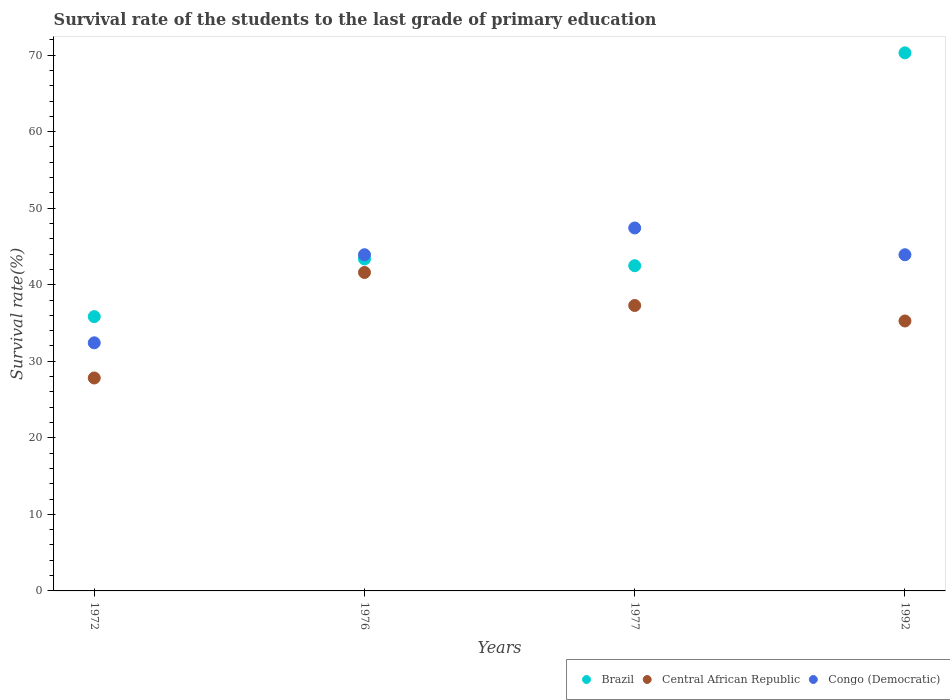How many different coloured dotlines are there?
Ensure brevity in your answer.  3. Is the number of dotlines equal to the number of legend labels?
Ensure brevity in your answer.  Yes. What is the survival rate of the students in Brazil in 1972?
Ensure brevity in your answer.  35.84. Across all years, what is the maximum survival rate of the students in Congo (Democratic)?
Make the answer very short. 47.42. Across all years, what is the minimum survival rate of the students in Brazil?
Provide a succinct answer. 35.84. In which year was the survival rate of the students in Central African Republic maximum?
Ensure brevity in your answer.  1976. What is the total survival rate of the students in Central African Republic in the graph?
Your answer should be very brief. 141.98. What is the difference between the survival rate of the students in Central African Republic in 1972 and that in 1992?
Provide a succinct answer. -7.45. What is the difference between the survival rate of the students in Brazil in 1992 and the survival rate of the students in Congo (Democratic) in 1976?
Give a very brief answer. 26.38. What is the average survival rate of the students in Congo (Democratic) per year?
Ensure brevity in your answer.  41.92. In the year 1992, what is the difference between the survival rate of the students in Brazil and survival rate of the students in Congo (Democratic)?
Offer a very short reply. 26.38. What is the ratio of the survival rate of the students in Congo (Democratic) in 1972 to that in 1977?
Your answer should be compact. 0.68. Is the survival rate of the students in Central African Republic in 1972 less than that in 1976?
Your answer should be very brief. Yes. What is the difference between the highest and the second highest survival rate of the students in Brazil?
Keep it short and to the point. 26.93. What is the difference between the highest and the lowest survival rate of the students in Central African Republic?
Make the answer very short. 13.79. Is the sum of the survival rate of the students in Brazil in 1976 and 1992 greater than the maximum survival rate of the students in Congo (Democratic) across all years?
Provide a succinct answer. Yes. Is the survival rate of the students in Congo (Democratic) strictly greater than the survival rate of the students in Central African Republic over the years?
Make the answer very short. Yes. Is the survival rate of the students in Central African Republic strictly less than the survival rate of the students in Brazil over the years?
Your response must be concise. Yes. How many dotlines are there?
Your answer should be compact. 3. How many years are there in the graph?
Your answer should be very brief. 4. What is the difference between two consecutive major ticks on the Y-axis?
Your answer should be very brief. 10. Are the values on the major ticks of Y-axis written in scientific E-notation?
Give a very brief answer. No. Does the graph contain any zero values?
Offer a terse response. No. Does the graph contain grids?
Make the answer very short. No. Where does the legend appear in the graph?
Ensure brevity in your answer.  Bottom right. How are the legend labels stacked?
Ensure brevity in your answer.  Horizontal. What is the title of the graph?
Your response must be concise. Survival rate of the students to the last grade of primary education. What is the label or title of the X-axis?
Offer a very short reply. Years. What is the label or title of the Y-axis?
Offer a terse response. Survival rate(%). What is the Survival rate(%) of Brazil in 1972?
Keep it short and to the point. 35.84. What is the Survival rate(%) of Central African Republic in 1972?
Your response must be concise. 27.82. What is the Survival rate(%) of Congo (Democratic) in 1972?
Your answer should be compact. 32.41. What is the Survival rate(%) of Brazil in 1976?
Provide a succinct answer. 43.37. What is the Survival rate(%) of Central African Republic in 1976?
Your answer should be very brief. 41.61. What is the Survival rate(%) in Congo (Democratic) in 1976?
Keep it short and to the point. 43.92. What is the Survival rate(%) of Brazil in 1977?
Offer a very short reply. 42.49. What is the Survival rate(%) of Central African Republic in 1977?
Your answer should be very brief. 37.29. What is the Survival rate(%) of Congo (Democratic) in 1977?
Your response must be concise. 47.42. What is the Survival rate(%) of Brazil in 1992?
Give a very brief answer. 70.3. What is the Survival rate(%) in Central African Republic in 1992?
Your answer should be very brief. 35.27. What is the Survival rate(%) of Congo (Democratic) in 1992?
Your answer should be compact. 43.92. Across all years, what is the maximum Survival rate(%) in Brazil?
Offer a terse response. 70.3. Across all years, what is the maximum Survival rate(%) of Central African Republic?
Your response must be concise. 41.61. Across all years, what is the maximum Survival rate(%) in Congo (Democratic)?
Offer a very short reply. 47.42. Across all years, what is the minimum Survival rate(%) of Brazil?
Give a very brief answer. 35.84. Across all years, what is the minimum Survival rate(%) of Central African Republic?
Keep it short and to the point. 27.82. Across all years, what is the minimum Survival rate(%) of Congo (Democratic)?
Ensure brevity in your answer.  32.41. What is the total Survival rate(%) in Brazil in the graph?
Your answer should be very brief. 192. What is the total Survival rate(%) of Central African Republic in the graph?
Ensure brevity in your answer.  141.98. What is the total Survival rate(%) in Congo (Democratic) in the graph?
Make the answer very short. 167.68. What is the difference between the Survival rate(%) of Brazil in 1972 and that in 1976?
Your response must be concise. -7.54. What is the difference between the Survival rate(%) in Central African Republic in 1972 and that in 1976?
Offer a very short reply. -13.79. What is the difference between the Survival rate(%) of Congo (Democratic) in 1972 and that in 1976?
Offer a terse response. -11.51. What is the difference between the Survival rate(%) in Brazil in 1972 and that in 1977?
Provide a short and direct response. -6.65. What is the difference between the Survival rate(%) of Central African Republic in 1972 and that in 1977?
Provide a succinct answer. -9.47. What is the difference between the Survival rate(%) of Congo (Democratic) in 1972 and that in 1977?
Your answer should be very brief. -15. What is the difference between the Survival rate(%) in Brazil in 1972 and that in 1992?
Offer a terse response. -34.46. What is the difference between the Survival rate(%) of Central African Republic in 1972 and that in 1992?
Your response must be concise. -7.45. What is the difference between the Survival rate(%) of Congo (Democratic) in 1972 and that in 1992?
Your response must be concise. -11.51. What is the difference between the Survival rate(%) of Brazil in 1976 and that in 1977?
Offer a very short reply. 0.89. What is the difference between the Survival rate(%) of Central African Republic in 1976 and that in 1977?
Ensure brevity in your answer.  4.31. What is the difference between the Survival rate(%) in Congo (Democratic) in 1976 and that in 1977?
Provide a short and direct response. -3.5. What is the difference between the Survival rate(%) in Brazil in 1976 and that in 1992?
Your answer should be compact. -26.93. What is the difference between the Survival rate(%) of Central African Republic in 1976 and that in 1992?
Keep it short and to the point. 6.34. What is the difference between the Survival rate(%) in Congo (Democratic) in 1976 and that in 1992?
Provide a succinct answer. 0. What is the difference between the Survival rate(%) in Brazil in 1977 and that in 1992?
Offer a very short reply. -27.81. What is the difference between the Survival rate(%) in Central African Republic in 1977 and that in 1992?
Offer a very short reply. 2.02. What is the difference between the Survival rate(%) of Congo (Democratic) in 1977 and that in 1992?
Provide a succinct answer. 3.5. What is the difference between the Survival rate(%) of Brazil in 1972 and the Survival rate(%) of Central African Republic in 1976?
Keep it short and to the point. -5.77. What is the difference between the Survival rate(%) in Brazil in 1972 and the Survival rate(%) in Congo (Democratic) in 1976?
Offer a terse response. -8.09. What is the difference between the Survival rate(%) of Central African Republic in 1972 and the Survival rate(%) of Congo (Democratic) in 1976?
Provide a short and direct response. -16.1. What is the difference between the Survival rate(%) of Brazil in 1972 and the Survival rate(%) of Central African Republic in 1977?
Your answer should be compact. -1.45. What is the difference between the Survival rate(%) in Brazil in 1972 and the Survival rate(%) in Congo (Democratic) in 1977?
Make the answer very short. -11.58. What is the difference between the Survival rate(%) of Central African Republic in 1972 and the Survival rate(%) of Congo (Democratic) in 1977?
Your response must be concise. -19.6. What is the difference between the Survival rate(%) in Brazil in 1972 and the Survival rate(%) in Central African Republic in 1992?
Offer a terse response. 0.57. What is the difference between the Survival rate(%) of Brazil in 1972 and the Survival rate(%) of Congo (Democratic) in 1992?
Keep it short and to the point. -8.08. What is the difference between the Survival rate(%) of Central African Republic in 1972 and the Survival rate(%) of Congo (Democratic) in 1992?
Keep it short and to the point. -16.1. What is the difference between the Survival rate(%) in Brazil in 1976 and the Survival rate(%) in Central African Republic in 1977?
Provide a short and direct response. 6.08. What is the difference between the Survival rate(%) of Brazil in 1976 and the Survival rate(%) of Congo (Democratic) in 1977?
Offer a terse response. -4.05. What is the difference between the Survival rate(%) in Central African Republic in 1976 and the Survival rate(%) in Congo (Democratic) in 1977?
Make the answer very short. -5.81. What is the difference between the Survival rate(%) in Brazil in 1976 and the Survival rate(%) in Central African Republic in 1992?
Provide a short and direct response. 8.11. What is the difference between the Survival rate(%) in Brazil in 1976 and the Survival rate(%) in Congo (Democratic) in 1992?
Offer a terse response. -0.55. What is the difference between the Survival rate(%) of Central African Republic in 1976 and the Survival rate(%) of Congo (Democratic) in 1992?
Give a very brief answer. -2.31. What is the difference between the Survival rate(%) of Brazil in 1977 and the Survival rate(%) of Central African Republic in 1992?
Offer a very short reply. 7.22. What is the difference between the Survival rate(%) of Brazil in 1977 and the Survival rate(%) of Congo (Democratic) in 1992?
Your answer should be very brief. -1.43. What is the difference between the Survival rate(%) of Central African Republic in 1977 and the Survival rate(%) of Congo (Democratic) in 1992?
Offer a terse response. -6.63. What is the average Survival rate(%) in Brazil per year?
Offer a very short reply. 48. What is the average Survival rate(%) in Central African Republic per year?
Your answer should be very brief. 35.5. What is the average Survival rate(%) of Congo (Democratic) per year?
Ensure brevity in your answer.  41.92. In the year 1972, what is the difference between the Survival rate(%) in Brazil and Survival rate(%) in Central African Republic?
Your answer should be very brief. 8.02. In the year 1972, what is the difference between the Survival rate(%) of Brazil and Survival rate(%) of Congo (Democratic)?
Your response must be concise. 3.42. In the year 1972, what is the difference between the Survival rate(%) in Central African Republic and Survival rate(%) in Congo (Democratic)?
Keep it short and to the point. -4.6. In the year 1976, what is the difference between the Survival rate(%) in Brazil and Survival rate(%) in Central African Republic?
Offer a very short reply. 1.77. In the year 1976, what is the difference between the Survival rate(%) of Brazil and Survival rate(%) of Congo (Democratic)?
Provide a succinct answer. -0.55. In the year 1976, what is the difference between the Survival rate(%) of Central African Republic and Survival rate(%) of Congo (Democratic)?
Provide a succinct answer. -2.32. In the year 1977, what is the difference between the Survival rate(%) of Brazil and Survival rate(%) of Central African Republic?
Give a very brief answer. 5.2. In the year 1977, what is the difference between the Survival rate(%) in Brazil and Survival rate(%) in Congo (Democratic)?
Make the answer very short. -4.93. In the year 1977, what is the difference between the Survival rate(%) in Central African Republic and Survival rate(%) in Congo (Democratic)?
Your answer should be very brief. -10.13. In the year 1992, what is the difference between the Survival rate(%) in Brazil and Survival rate(%) in Central African Republic?
Ensure brevity in your answer.  35.03. In the year 1992, what is the difference between the Survival rate(%) of Brazil and Survival rate(%) of Congo (Democratic)?
Your response must be concise. 26.38. In the year 1992, what is the difference between the Survival rate(%) of Central African Republic and Survival rate(%) of Congo (Democratic)?
Give a very brief answer. -8.65. What is the ratio of the Survival rate(%) of Brazil in 1972 to that in 1976?
Offer a terse response. 0.83. What is the ratio of the Survival rate(%) in Central African Republic in 1972 to that in 1976?
Offer a very short reply. 0.67. What is the ratio of the Survival rate(%) of Congo (Democratic) in 1972 to that in 1976?
Ensure brevity in your answer.  0.74. What is the ratio of the Survival rate(%) of Brazil in 1972 to that in 1977?
Make the answer very short. 0.84. What is the ratio of the Survival rate(%) in Central African Republic in 1972 to that in 1977?
Provide a short and direct response. 0.75. What is the ratio of the Survival rate(%) in Congo (Democratic) in 1972 to that in 1977?
Offer a very short reply. 0.68. What is the ratio of the Survival rate(%) in Brazil in 1972 to that in 1992?
Your answer should be compact. 0.51. What is the ratio of the Survival rate(%) of Central African Republic in 1972 to that in 1992?
Provide a succinct answer. 0.79. What is the ratio of the Survival rate(%) in Congo (Democratic) in 1972 to that in 1992?
Keep it short and to the point. 0.74. What is the ratio of the Survival rate(%) of Brazil in 1976 to that in 1977?
Offer a terse response. 1.02. What is the ratio of the Survival rate(%) of Central African Republic in 1976 to that in 1977?
Make the answer very short. 1.12. What is the ratio of the Survival rate(%) in Congo (Democratic) in 1976 to that in 1977?
Provide a short and direct response. 0.93. What is the ratio of the Survival rate(%) in Brazil in 1976 to that in 1992?
Offer a very short reply. 0.62. What is the ratio of the Survival rate(%) of Central African Republic in 1976 to that in 1992?
Keep it short and to the point. 1.18. What is the ratio of the Survival rate(%) of Congo (Democratic) in 1976 to that in 1992?
Offer a very short reply. 1. What is the ratio of the Survival rate(%) in Brazil in 1977 to that in 1992?
Offer a very short reply. 0.6. What is the ratio of the Survival rate(%) of Central African Republic in 1977 to that in 1992?
Your answer should be compact. 1.06. What is the ratio of the Survival rate(%) of Congo (Democratic) in 1977 to that in 1992?
Provide a short and direct response. 1.08. What is the difference between the highest and the second highest Survival rate(%) of Brazil?
Offer a terse response. 26.93. What is the difference between the highest and the second highest Survival rate(%) in Central African Republic?
Offer a terse response. 4.31. What is the difference between the highest and the second highest Survival rate(%) in Congo (Democratic)?
Ensure brevity in your answer.  3.5. What is the difference between the highest and the lowest Survival rate(%) of Brazil?
Offer a very short reply. 34.46. What is the difference between the highest and the lowest Survival rate(%) of Central African Republic?
Provide a short and direct response. 13.79. What is the difference between the highest and the lowest Survival rate(%) of Congo (Democratic)?
Ensure brevity in your answer.  15. 